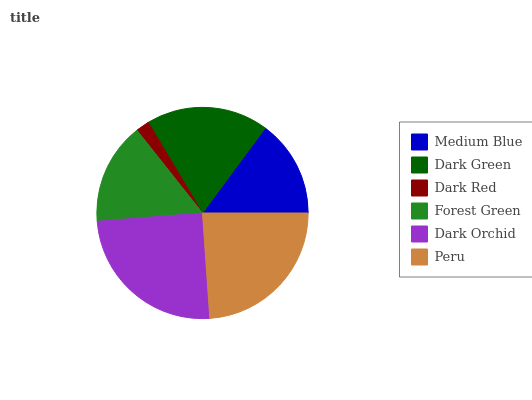Is Dark Red the minimum?
Answer yes or no. Yes. Is Dark Orchid the maximum?
Answer yes or no. Yes. Is Dark Green the minimum?
Answer yes or no. No. Is Dark Green the maximum?
Answer yes or no. No. Is Dark Green greater than Medium Blue?
Answer yes or no. Yes. Is Medium Blue less than Dark Green?
Answer yes or no. Yes. Is Medium Blue greater than Dark Green?
Answer yes or no. No. Is Dark Green less than Medium Blue?
Answer yes or no. No. Is Dark Green the high median?
Answer yes or no. Yes. Is Forest Green the low median?
Answer yes or no. Yes. Is Dark Orchid the high median?
Answer yes or no. No. Is Dark Red the low median?
Answer yes or no. No. 